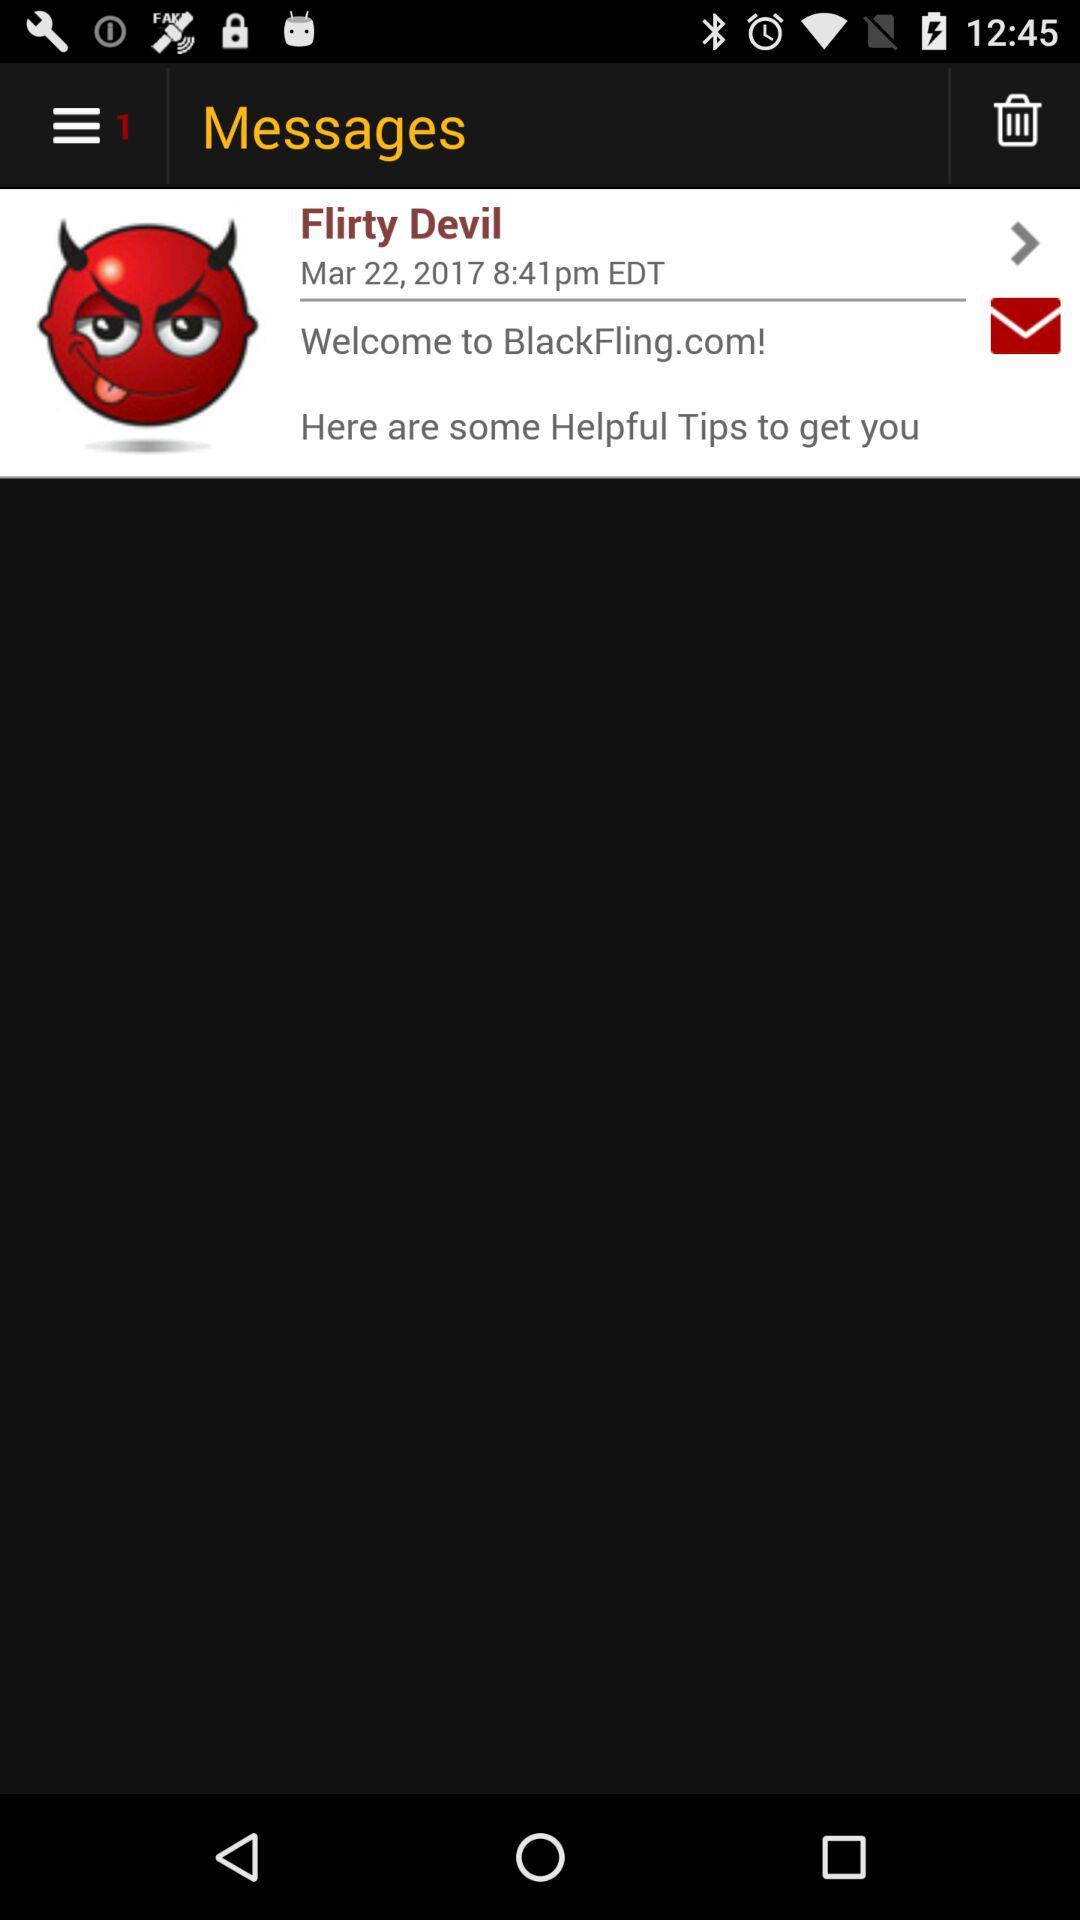What is the date? The date is March 22, 2017. 